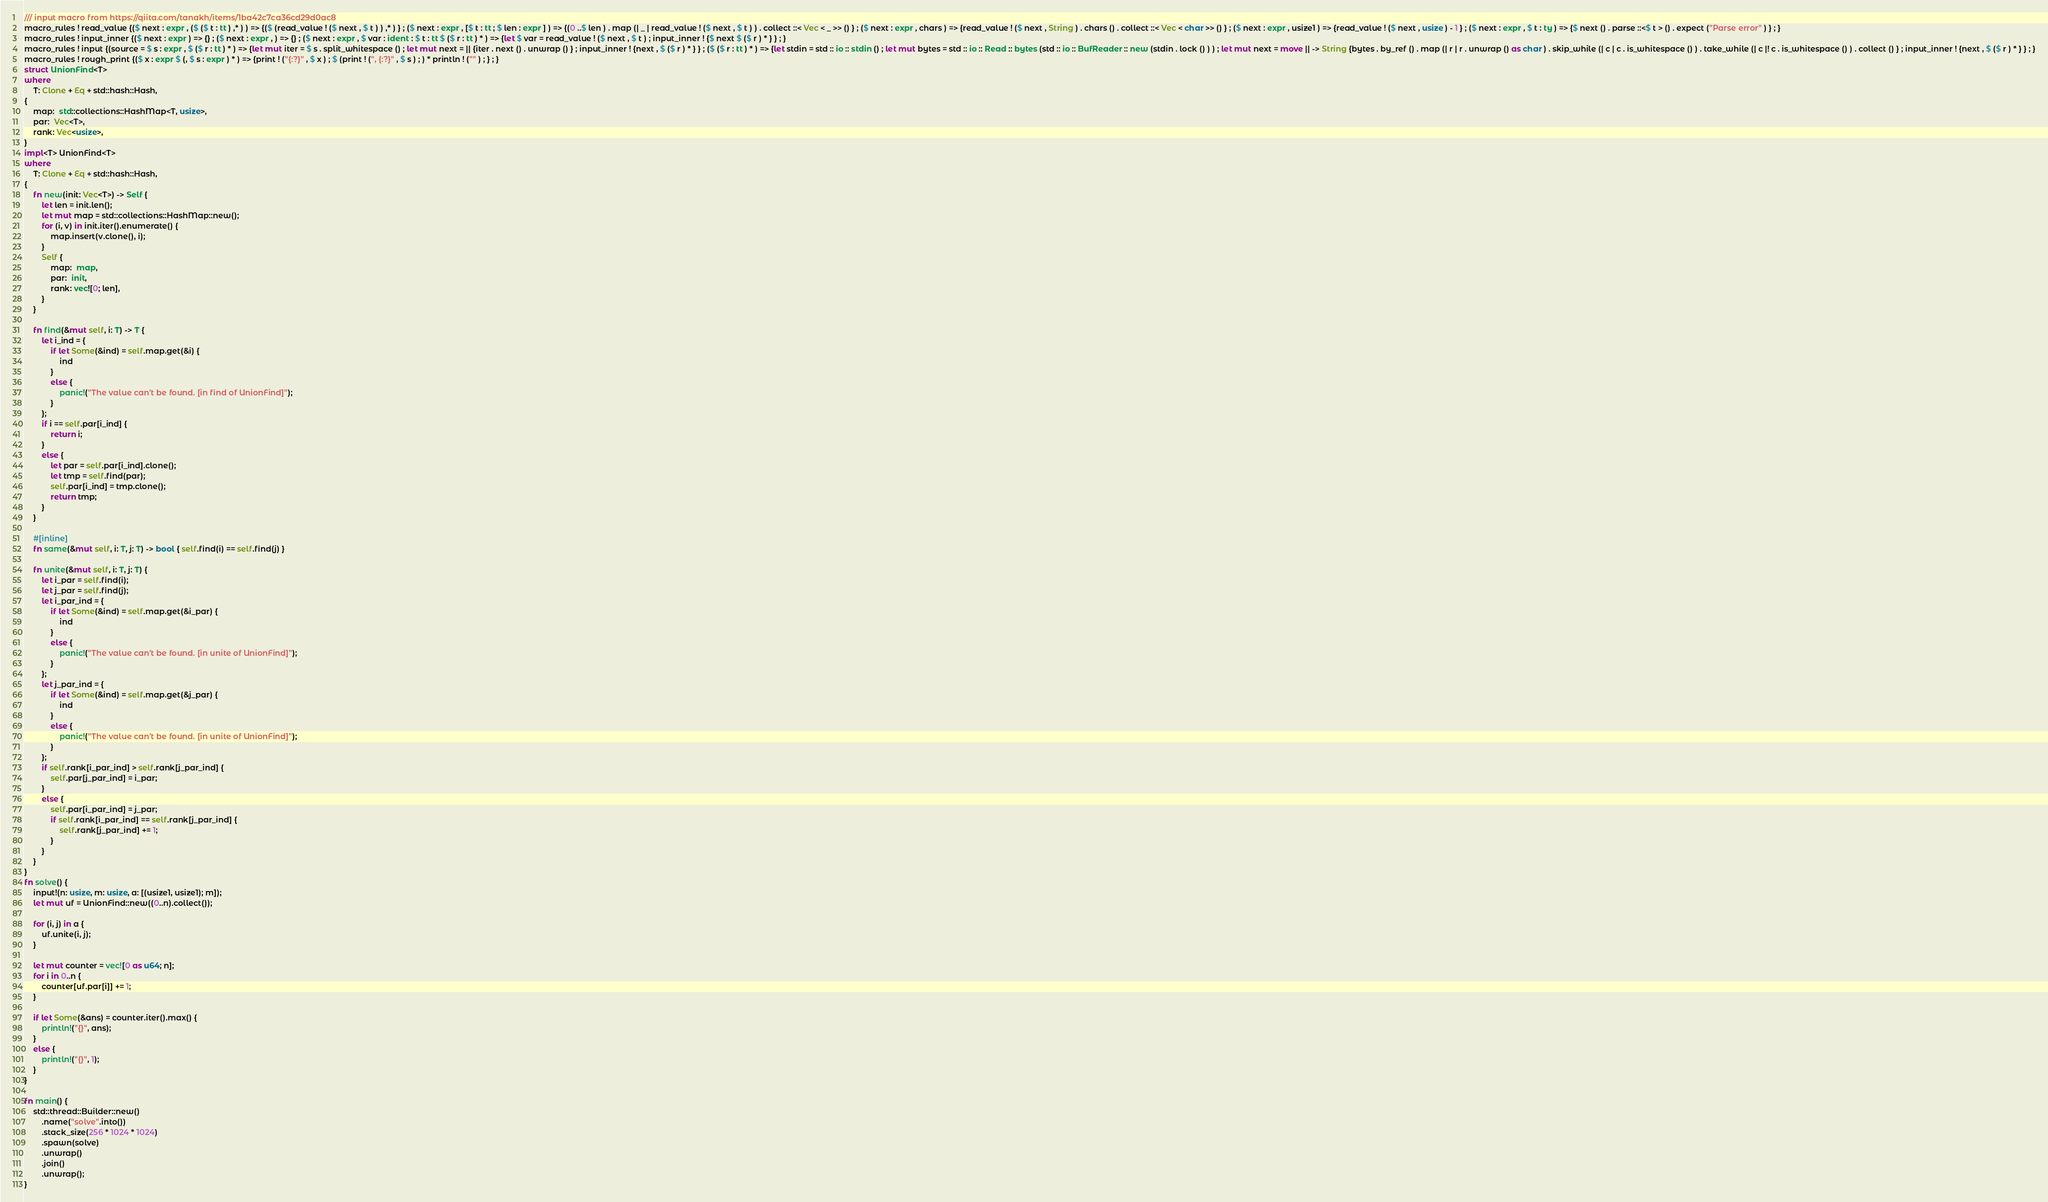<code> <loc_0><loc_0><loc_500><loc_500><_Rust_>/// input macro from https://qiita.com/tanakh/items/1ba42c7ca36cd29d0ac8
macro_rules ! read_value {($ next : expr , ($ ($ t : tt ) ,* ) ) => {($ (read_value ! ($ next , $ t ) ) ,* ) } ; ($ next : expr , [$ t : tt ; $ len : expr ] ) => {(0 ..$ len ) . map (| _ | read_value ! ($ next , $ t ) ) . collect ::< Vec < _ >> () } ; ($ next : expr , chars ) => {read_value ! ($ next , String ) . chars () . collect ::< Vec < char >> () } ; ($ next : expr , usize1 ) => {read_value ! ($ next , usize ) - 1 } ; ($ next : expr , $ t : ty ) => {$ next () . parse ::<$ t > () . expect ("Parse error" ) } ; }
macro_rules ! input_inner {($ next : expr ) => {} ; ($ next : expr , ) => {} ; ($ next : expr , $ var : ident : $ t : tt $ ($ r : tt ) * ) => {let $ var = read_value ! ($ next , $ t ) ; input_inner ! {$ next $ ($ r ) * } } ; }
macro_rules ! input {(source = $ s : expr , $ ($ r : tt ) * ) => {let mut iter = $ s . split_whitespace () ; let mut next = || {iter . next () . unwrap () } ; input_inner ! {next , $ ($ r ) * } } ; ($ ($ r : tt ) * ) => {let stdin = std :: io :: stdin () ; let mut bytes = std :: io :: Read :: bytes (std :: io :: BufReader :: new (stdin . lock () ) ) ; let mut next = move || -> String {bytes . by_ref () . map (| r | r . unwrap () as char ) . skip_while (| c | c . is_whitespace () ) . take_while (| c |! c . is_whitespace () ) . collect () } ; input_inner ! {next , $ ($ r ) * } } ; }
macro_rules ! rough_print {($ x : expr $ (, $ s : expr ) * ) => {print ! ("{:?}" , $ x ) ; $ (print ! (", {:?}" , $ s ) ; ) * println ! ("" ) ; } ; }
struct UnionFind<T>
where
    T: Clone + Eq + std::hash::Hash,
{
    map:  std::collections::HashMap<T, usize>,
    par:  Vec<T>,
    rank: Vec<usize>,
}
impl<T> UnionFind<T>
where
    T: Clone + Eq + std::hash::Hash,
{
    fn new(init: Vec<T>) -> Self {
        let len = init.len();
        let mut map = std::collections::HashMap::new();
        for (i, v) in init.iter().enumerate() {
            map.insert(v.clone(), i);
        }
        Self {
            map:  map,
            par:  init,
            rank: vec![0; len],
        }
    }

    fn find(&mut self, i: T) -> T {
        let i_ind = {
            if let Some(&ind) = self.map.get(&i) {
                ind
            }
            else {
                panic!("The value can't be found. [in find of UnionFind]");
            }
        };
        if i == self.par[i_ind] {
            return i;
        }
        else {
            let par = self.par[i_ind].clone();
            let tmp = self.find(par);
            self.par[i_ind] = tmp.clone();
            return tmp;
        }
    }

    #[inline]
    fn same(&mut self, i: T, j: T) -> bool { self.find(i) == self.find(j) }

    fn unite(&mut self, i: T, j: T) {
        let i_par = self.find(i);
        let j_par = self.find(j);
        let i_par_ind = {
            if let Some(&ind) = self.map.get(&i_par) {
                ind
            }
            else {
                panic!("The value can't be found. [in unite of UnionFind]");
            }
        };
        let j_par_ind = {
            if let Some(&ind) = self.map.get(&j_par) {
                ind
            }
            else {
                panic!("The value can't be found. [in unite of UnionFind]");
            }
        };
        if self.rank[i_par_ind] > self.rank[j_par_ind] {
            self.par[j_par_ind] = i_par;
        }
        else {
            self.par[i_par_ind] = j_par;
            if self.rank[i_par_ind] == self.rank[j_par_ind] {
                self.rank[j_par_ind] += 1;
            }
        }
    }
}
fn solve() {
    input!(n: usize, m: usize, a: [(usize1, usize1); m]);
    let mut uf = UnionFind::new((0..n).collect());

    for (i, j) in a {
        uf.unite(i, j);
    }

    let mut counter = vec![0 as u64; n];
    for i in 0..n {
        counter[uf.par[i]] += 1;
    }

    if let Some(&ans) = counter.iter().max() {
        println!("{}", ans);
    }
    else {
        println!("{}", 1);
    }
}

fn main() {
    std::thread::Builder::new()
        .name("solve".into())
        .stack_size(256 * 1024 * 1024)
        .spawn(solve)
        .unwrap()
        .join()
        .unwrap();
}
</code> 